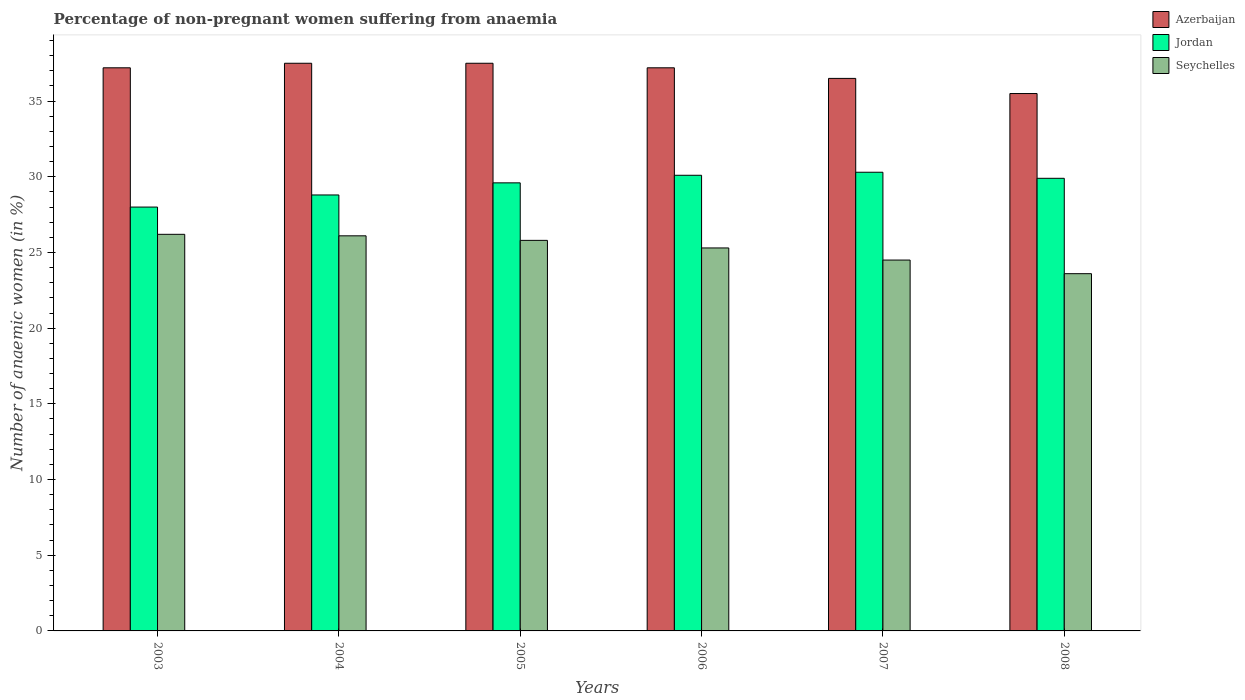How many different coloured bars are there?
Provide a succinct answer. 3. How many groups of bars are there?
Your answer should be compact. 6. Are the number of bars per tick equal to the number of legend labels?
Provide a short and direct response. Yes. What is the label of the 2nd group of bars from the left?
Keep it short and to the point. 2004. What is the percentage of non-pregnant women suffering from anaemia in Azerbaijan in 2004?
Give a very brief answer. 37.5. Across all years, what is the maximum percentage of non-pregnant women suffering from anaemia in Azerbaijan?
Your answer should be compact. 37.5. Across all years, what is the minimum percentage of non-pregnant women suffering from anaemia in Azerbaijan?
Your answer should be compact. 35.5. In which year was the percentage of non-pregnant women suffering from anaemia in Seychelles minimum?
Make the answer very short. 2008. What is the total percentage of non-pregnant women suffering from anaemia in Seychelles in the graph?
Your answer should be very brief. 151.5. What is the difference between the percentage of non-pregnant women suffering from anaemia in Azerbaijan in 2006 and that in 2007?
Keep it short and to the point. 0.7. What is the average percentage of non-pregnant women suffering from anaemia in Seychelles per year?
Give a very brief answer. 25.25. In the year 2004, what is the difference between the percentage of non-pregnant women suffering from anaemia in Seychelles and percentage of non-pregnant women suffering from anaemia in Jordan?
Ensure brevity in your answer.  -2.7. What is the ratio of the percentage of non-pregnant women suffering from anaemia in Jordan in 2006 to that in 2008?
Your answer should be very brief. 1.01. Is the percentage of non-pregnant women suffering from anaemia in Jordan in 2005 less than that in 2006?
Give a very brief answer. Yes. Is the difference between the percentage of non-pregnant women suffering from anaemia in Seychelles in 2007 and 2008 greater than the difference between the percentage of non-pregnant women suffering from anaemia in Jordan in 2007 and 2008?
Make the answer very short. Yes. What is the difference between the highest and the second highest percentage of non-pregnant women suffering from anaemia in Seychelles?
Your response must be concise. 0.1. What does the 3rd bar from the left in 2007 represents?
Offer a terse response. Seychelles. What does the 2nd bar from the right in 2006 represents?
Ensure brevity in your answer.  Jordan. Is it the case that in every year, the sum of the percentage of non-pregnant women suffering from anaemia in Jordan and percentage of non-pregnant women suffering from anaemia in Seychelles is greater than the percentage of non-pregnant women suffering from anaemia in Azerbaijan?
Keep it short and to the point. Yes. How many bars are there?
Provide a succinct answer. 18. How many years are there in the graph?
Make the answer very short. 6. Does the graph contain grids?
Provide a succinct answer. No. Where does the legend appear in the graph?
Give a very brief answer. Top right. What is the title of the graph?
Ensure brevity in your answer.  Percentage of non-pregnant women suffering from anaemia. Does "Kosovo" appear as one of the legend labels in the graph?
Keep it short and to the point. No. What is the label or title of the X-axis?
Your answer should be very brief. Years. What is the label or title of the Y-axis?
Provide a short and direct response. Number of anaemic women (in %). What is the Number of anaemic women (in %) in Azerbaijan in 2003?
Ensure brevity in your answer.  37.2. What is the Number of anaemic women (in %) of Seychelles in 2003?
Your answer should be compact. 26.2. What is the Number of anaemic women (in %) in Azerbaijan in 2004?
Your answer should be very brief. 37.5. What is the Number of anaemic women (in %) in Jordan in 2004?
Your answer should be compact. 28.8. What is the Number of anaemic women (in %) in Seychelles in 2004?
Make the answer very short. 26.1. What is the Number of anaemic women (in %) in Azerbaijan in 2005?
Give a very brief answer. 37.5. What is the Number of anaemic women (in %) of Jordan in 2005?
Offer a terse response. 29.6. What is the Number of anaemic women (in %) of Seychelles in 2005?
Your answer should be compact. 25.8. What is the Number of anaemic women (in %) in Azerbaijan in 2006?
Provide a short and direct response. 37.2. What is the Number of anaemic women (in %) in Jordan in 2006?
Provide a succinct answer. 30.1. What is the Number of anaemic women (in %) of Seychelles in 2006?
Your response must be concise. 25.3. What is the Number of anaemic women (in %) in Azerbaijan in 2007?
Ensure brevity in your answer.  36.5. What is the Number of anaemic women (in %) in Jordan in 2007?
Your answer should be compact. 30.3. What is the Number of anaemic women (in %) of Azerbaijan in 2008?
Offer a very short reply. 35.5. What is the Number of anaemic women (in %) of Jordan in 2008?
Provide a succinct answer. 29.9. What is the Number of anaemic women (in %) of Seychelles in 2008?
Your response must be concise. 23.6. Across all years, what is the maximum Number of anaemic women (in %) in Azerbaijan?
Ensure brevity in your answer.  37.5. Across all years, what is the maximum Number of anaemic women (in %) of Jordan?
Ensure brevity in your answer.  30.3. Across all years, what is the maximum Number of anaemic women (in %) of Seychelles?
Your response must be concise. 26.2. Across all years, what is the minimum Number of anaemic women (in %) of Azerbaijan?
Your answer should be compact. 35.5. Across all years, what is the minimum Number of anaemic women (in %) in Jordan?
Offer a very short reply. 28. Across all years, what is the minimum Number of anaemic women (in %) in Seychelles?
Your response must be concise. 23.6. What is the total Number of anaemic women (in %) of Azerbaijan in the graph?
Offer a terse response. 221.4. What is the total Number of anaemic women (in %) of Jordan in the graph?
Offer a very short reply. 176.7. What is the total Number of anaemic women (in %) in Seychelles in the graph?
Offer a terse response. 151.5. What is the difference between the Number of anaemic women (in %) in Azerbaijan in 2003 and that in 2005?
Offer a very short reply. -0.3. What is the difference between the Number of anaemic women (in %) in Seychelles in 2003 and that in 2007?
Make the answer very short. 1.7. What is the difference between the Number of anaemic women (in %) in Azerbaijan in 2003 and that in 2008?
Provide a short and direct response. 1.7. What is the difference between the Number of anaemic women (in %) in Seychelles in 2003 and that in 2008?
Keep it short and to the point. 2.6. What is the difference between the Number of anaemic women (in %) in Azerbaijan in 2004 and that in 2005?
Offer a very short reply. 0. What is the difference between the Number of anaemic women (in %) of Azerbaijan in 2004 and that in 2006?
Ensure brevity in your answer.  0.3. What is the difference between the Number of anaemic women (in %) in Jordan in 2004 and that in 2006?
Your answer should be compact. -1.3. What is the difference between the Number of anaemic women (in %) in Seychelles in 2004 and that in 2008?
Your answer should be compact. 2.5. What is the difference between the Number of anaemic women (in %) in Jordan in 2005 and that in 2006?
Offer a terse response. -0.5. What is the difference between the Number of anaemic women (in %) of Azerbaijan in 2006 and that in 2007?
Give a very brief answer. 0.7. What is the difference between the Number of anaemic women (in %) in Jordan in 2006 and that in 2007?
Offer a terse response. -0.2. What is the difference between the Number of anaemic women (in %) in Seychelles in 2006 and that in 2007?
Offer a terse response. 0.8. What is the difference between the Number of anaemic women (in %) in Azerbaijan in 2006 and that in 2008?
Your answer should be very brief. 1.7. What is the difference between the Number of anaemic women (in %) in Jordan in 2007 and that in 2008?
Give a very brief answer. 0.4. What is the difference between the Number of anaemic women (in %) of Azerbaijan in 2003 and the Number of anaemic women (in %) of Seychelles in 2004?
Ensure brevity in your answer.  11.1. What is the difference between the Number of anaemic women (in %) of Jordan in 2003 and the Number of anaemic women (in %) of Seychelles in 2004?
Your answer should be compact. 1.9. What is the difference between the Number of anaemic women (in %) of Azerbaijan in 2003 and the Number of anaemic women (in %) of Jordan in 2005?
Give a very brief answer. 7.6. What is the difference between the Number of anaemic women (in %) in Azerbaijan in 2003 and the Number of anaemic women (in %) in Jordan in 2006?
Provide a short and direct response. 7.1. What is the difference between the Number of anaemic women (in %) in Azerbaijan in 2003 and the Number of anaemic women (in %) in Seychelles in 2006?
Offer a very short reply. 11.9. What is the difference between the Number of anaemic women (in %) in Azerbaijan in 2003 and the Number of anaemic women (in %) in Jordan in 2007?
Make the answer very short. 6.9. What is the difference between the Number of anaemic women (in %) in Azerbaijan in 2003 and the Number of anaemic women (in %) in Seychelles in 2007?
Your answer should be very brief. 12.7. What is the difference between the Number of anaemic women (in %) of Jordan in 2003 and the Number of anaemic women (in %) of Seychelles in 2007?
Give a very brief answer. 3.5. What is the difference between the Number of anaemic women (in %) of Azerbaijan in 2003 and the Number of anaemic women (in %) of Jordan in 2008?
Give a very brief answer. 7.3. What is the difference between the Number of anaemic women (in %) in Azerbaijan in 2004 and the Number of anaemic women (in %) in Jordan in 2005?
Give a very brief answer. 7.9. What is the difference between the Number of anaemic women (in %) of Azerbaijan in 2004 and the Number of anaemic women (in %) of Seychelles in 2005?
Offer a very short reply. 11.7. What is the difference between the Number of anaemic women (in %) of Jordan in 2004 and the Number of anaemic women (in %) of Seychelles in 2005?
Your response must be concise. 3. What is the difference between the Number of anaemic women (in %) in Azerbaijan in 2004 and the Number of anaemic women (in %) in Seychelles in 2006?
Your answer should be very brief. 12.2. What is the difference between the Number of anaemic women (in %) in Azerbaijan in 2004 and the Number of anaemic women (in %) in Seychelles in 2007?
Provide a succinct answer. 13. What is the difference between the Number of anaemic women (in %) of Azerbaijan in 2004 and the Number of anaemic women (in %) of Seychelles in 2008?
Ensure brevity in your answer.  13.9. What is the difference between the Number of anaemic women (in %) in Azerbaijan in 2005 and the Number of anaemic women (in %) in Jordan in 2006?
Keep it short and to the point. 7.4. What is the difference between the Number of anaemic women (in %) of Jordan in 2005 and the Number of anaemic women (in %) of Seychelles in 2006?
Ensure brevity in your answer.  4.3. What is the difference between the Number of anaemic women (in %) in Azerbaijan in 2005 and the Number of anaemic women (in %) in Jordan in 2008?
Ensure brevity in your answer.  7.6. What is the difference between the Number of anaemic women (in %) of Azerbaijan in 2006 and the Number of anaemic women (in %) of Jordan in 2007?
Ensure brevity in your answer.  6.9. What is the difference between the Number of anaemic women (in %) in Azerbaijan in 2006 and the Number of anaemic women (in %) in Seychelles in 2007?
Keep it short and to the point. 12.7. What is the difference between the Number of anaemic women (in %) of Azerbaijan in 2006 and the Number of anaemic women (in %) of Jordan in 2008?
Make the answer very short. 7.3. What is the difference between the Number of anaemic women (in %) in Azerbaijan in 2006 and the Number of anaemic women (in %) in Seychelles in 2008?
Provide a short and direct response. 13.6. What is the difference between the Number of anaemic women (in %) of Jordan in 2006 and the Number of anaemic women (in %) of Seychelles in 2008?
Make the answer very short. 6.5. What is the average Number of anaemic women (in %) in Azerbaijan per year?
Your response must be concise. 36.9. What is the average Number of anaemic women (in %) of Jordan per year?
Provide a short and direct response. 29.45. What is the average Number of anaemic women (in %) of Seychelles per year?
Provide a short and direct response. 25.25. In the year 2003, what is the difference between the Number of anaemic women (in %) of Azerbaijan and Number of anaemic women (in %) of Jordan?
Offer a very short reply. 9.2. In the year 2003, what is the difference between the Number of anaemic women (in %) in Azerbaijan and Number of anaemic women (in %) in Seychelles?
Provide a short and direct response. 11. In the year 2004, what is the difference between the Number of anaemic women (in %) in Azerbaijan and Number of anaemic women (in %) in Jordan?
Your answer should be very brief. 8.7. In the year 2004, what is the difference between the Number of anaemic women (in %) in Azerbaijan and Number of anaemic women (in %) in Seychelles?
Make the answer very short. 11.4. In the year 2005, what is the difference between the Number of anaemic women (in %) of Jordan and Number of anaemic women (in %) of Seychelles?
Your answer should be compact. 3.8. In the year 2006, what is the difference between the Number of anaemic women (in %) in Azerbaijan and Number of anaemic women (in %) in Seychelles?
Your answer should be very brief. 11.9. In the year 2006, what is the difference between the Number of anaemic women (in %) of Jordan and Number of anaemic women (in %) of Seychelles?
Provide a succinct answer. 4.8. In the year 2007, what is the difference between the Number of anaemic women (in %) of Azerbaijan and Number of anaemic women (in %) of Jordan?
Give a very brief answer. 6.2. In the year 2007, what is the difference between the Number of anaemic women (in %) in Azerbaijan and Number of anaemic women (in %) in Seychelles?
Offer a very short reply. 12. In the year 2007, what is the difference between the Number of anaemic women (in %) in Jordan and Number of anaemic women (in %) in Seychelles?
Your answer should be compact. 5.8. In the year 2008, what is the difference between the Number of anaemic women (in %) in Jordan and Number of anaemic women (in %) in Seychelles?
Offer a very short reply. 6.3. What is the ratio of the Number of anaemic women (in %) in Jordan in 2003 to that in 2004?
Your answer should be very brief. 0.97. What is the ratio of the Number of anaemic women (in %) of Seychelles in 2003 to that in 2004?
Your response must be concise. 1. What is the ratio of the Number of anaemic women (in %) in Azerbaijan in 2003 to that in 2005?
Make the answer very short. 0.99. What is the ratio of the Number of anaemic women (in %) of Jordan in 2003 to that in 2005?
Give a very brief answer. 0.95. What is the ratio of the Number of anaemic women (in %) of Seychelles in 2003 to that in 2005?
Offer a very short reply. 1.02. What is the ratio of the Number of anaemic women (in %) of Azerbaijan in 2003 to that in 2006?
Give a very brief answer. 1. What is the ratio of the Number of anaemic women (in %) in Jordan in 2003 to that in 2006?
Offer a terse response. 0.93. What is the ratio of the Number of anaemic women (in %) of Seychelles in 2003 to that in 2006?
Offer a terse response. 1.04. What is the ratio of the Number of anaemic women (in %) of Azerbaijan in 2003 to that in 2007?
Provide a short and direct response. 1.02. What is the ratio of the Number of anaemic women (in %) of Jordan in 2003 to that in 2007?
Provide a succinct answer. 0.92. What is the ratio of the Number of anaemic women (in %) in Seychelles in 2003 to that in 2007?
Offer a terse response. 1.07. What is the ratio of the Number of anaemic women (in %) of Azerbaijan in 2003 to that in 2008?
Your response must be concise. 1.05. What is the ratio of the Number of anaemic women (in %) in Jordan in 2003 to that in 2008?
Your answer should be compact. 0.94. What is the ratio of the Number of anaemic women (in %) of Seychelles in 2003 to that in 2008?
Your answer should be very brief. 1.11. What is the ratio of the Number of anaemic women (in %) in Azerbaijan in 2004 to that in 2005?
Your answer should be very brief. 1. What is the ratio of the Number of anaemic women (in %) in Jordan in 2004 to that in 2005?
Offer a terse response. 0.97. What is the ratio of the Number of anaemic women (in %) in Seychelles in 2004 to that in 2005?
Your response must be concise. 1.01. What is the ratio of the Number of anaemic women (in %) of Jordan in 2004 to that in 2006?
Your answer should be very brief. 0.96. What is the ratio of the Number of anaemic women (in %) in Seychelles in 2004 to that in 2006?
Your response must be concise. 1.03. What is the ratio of the Number of anaemic women (in %) of Azerbaijan in 2004 to that in 2007?
Your answer should be compact. 1.03. What is the ratio of the Number of anaemic women (in %) of Jordan in 2004 to that in 2007?
Ensure brevity in your answer.  0.95. What is the ratio of the Number of anaemic women (in %) in Seychelles in 2004 to that in 2007?
Provide a short and direct response. 1.07. What is the ratio of the Number of anaemic women (in %) in Azerbaijan in 2004 to that in 2008?
Provide a succinct answer. 1.06. What is the ratio of the Number of anaemic women (in %) in Jordan in 2004 to that in 2008?
Your response must be concise. 0.96. What is the ratio of the Number of anaemic women (in %) in Seychelles in 2004 to that in 2008?
Offer a very short reply. 1.11. What is the ratio of the Number of anaemic women (in %) in Jordan in 2005 to that in 2006?
Your answer should be very brief. 0.98. What is the ratio of the Number of anaemic women (in %) of Seychelles in 2005 to that in 2006?
Your answer should be very brief. 1.02. What is the ratio of the Number of anaemic women (in %) of Azerbaijan in 2005 to that in 2007?
Your answer should be very brief. 1.03. What is the ratio of the Number of anaemic women (in %) of Jordan in 2005 to that in 2007?
Your answer should be very brief. 0.98. What is the ratio of the Number of anaemic women (in %) in Seychelles in 2005 to that in 2007?
Give a very brief answer. 1.05. What is the ratio of the Number of anaemic women (in %) of Azerbaijan in 2005 to that in 2008?
Offer a terse response. 1.06. What is the ratio of the Number of anaemic women (in %) in Seychelles in 2005 to that in 2008?
Give a very brief answer. 1.09. What is the ratio of the Number of anaemic women (in %) in Azerbaijan in 2006 to that in 2007?
Your answer should be very brief. 1.02. What is the ratio of the Number of anaemic women (in %) of Seychelles in 2006 to that in 2007?
Give a very brief answer. 1.03. What is the ratio of the Number of anaemic women (in %) in Azerbaijan in 2006 to that in 2008?
Give a very brief answer. 1.05. What is the ratio of the Number of anaemic women (in %) of Seychelles in 2006 to that in 2008?
Provide a succinct answer. 1.07. What is the ratio of the Number of anaemic women (in %) in Azerbaijan in 2007 to that in 2008?
Provide a short and direct response. 1.03. What is the ratio of the Number of anaemic women (in %) in Jordan in 2007 to that in 2008?
Keep it short and to the point. 1.01. What is the ratio of the Number of anaemic women (in %) in Seychelles in 2007 to that in 2008?
Provide a short and direct response. 1.04. What is the difference between the highest and the second highest Number of anaemic women (in %) in Azerbaijan?
Give a very brief answer. 0. What is the difference between the highest and the lowest Number of anaemic women (in %) of Azerbaijan?
Your answer should be compact. 2. What is the difference between the highest and the lowest Number of anaemic women (in %) in Jordan?
Your answer should be compact. 2.3. 